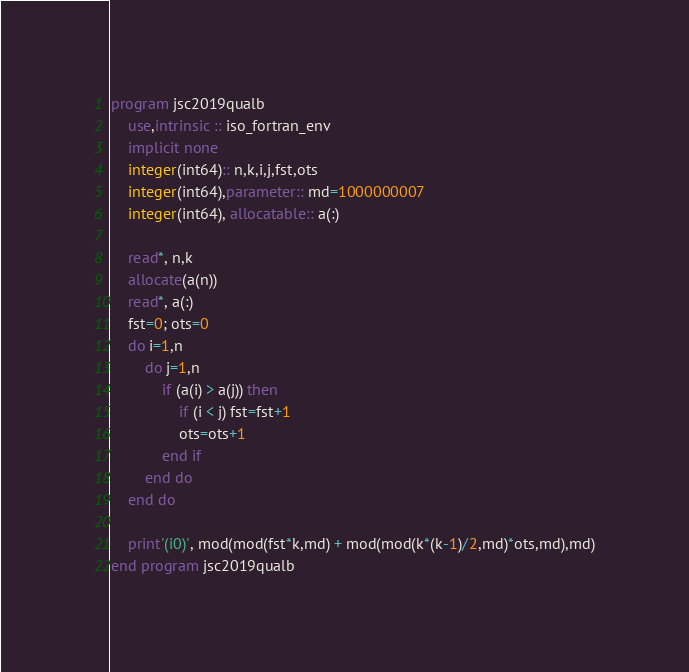Convert code to text. <code><loc_0><loc_0><loc_500><loc_500><_FORTRAN_>program jsc2019qualb
    use,intrinsic :: iso_fortran_env
    implicit none
    integer(int64):: n,k,i,j,fst,ots
    integer(int64),parameter:: md=1000000007
    integer(int64), allocatable:: a(:)
    
    read*, n,k
    allocate(a(n))
    read*, a(:)
    fst=0; ots=0
    do i=1,n
        do j=1,n
            if (a(i) > a(j)) then
                if (i < j) fst=fst+1
                ots=ots+1
            end if
        end do
    end do
    
    print'(i0)', mod(mod(fst*k,md) + mod(mod(k*(k-1)/2,md)*ots,md),md)
end program jsc2019qualb</code> 